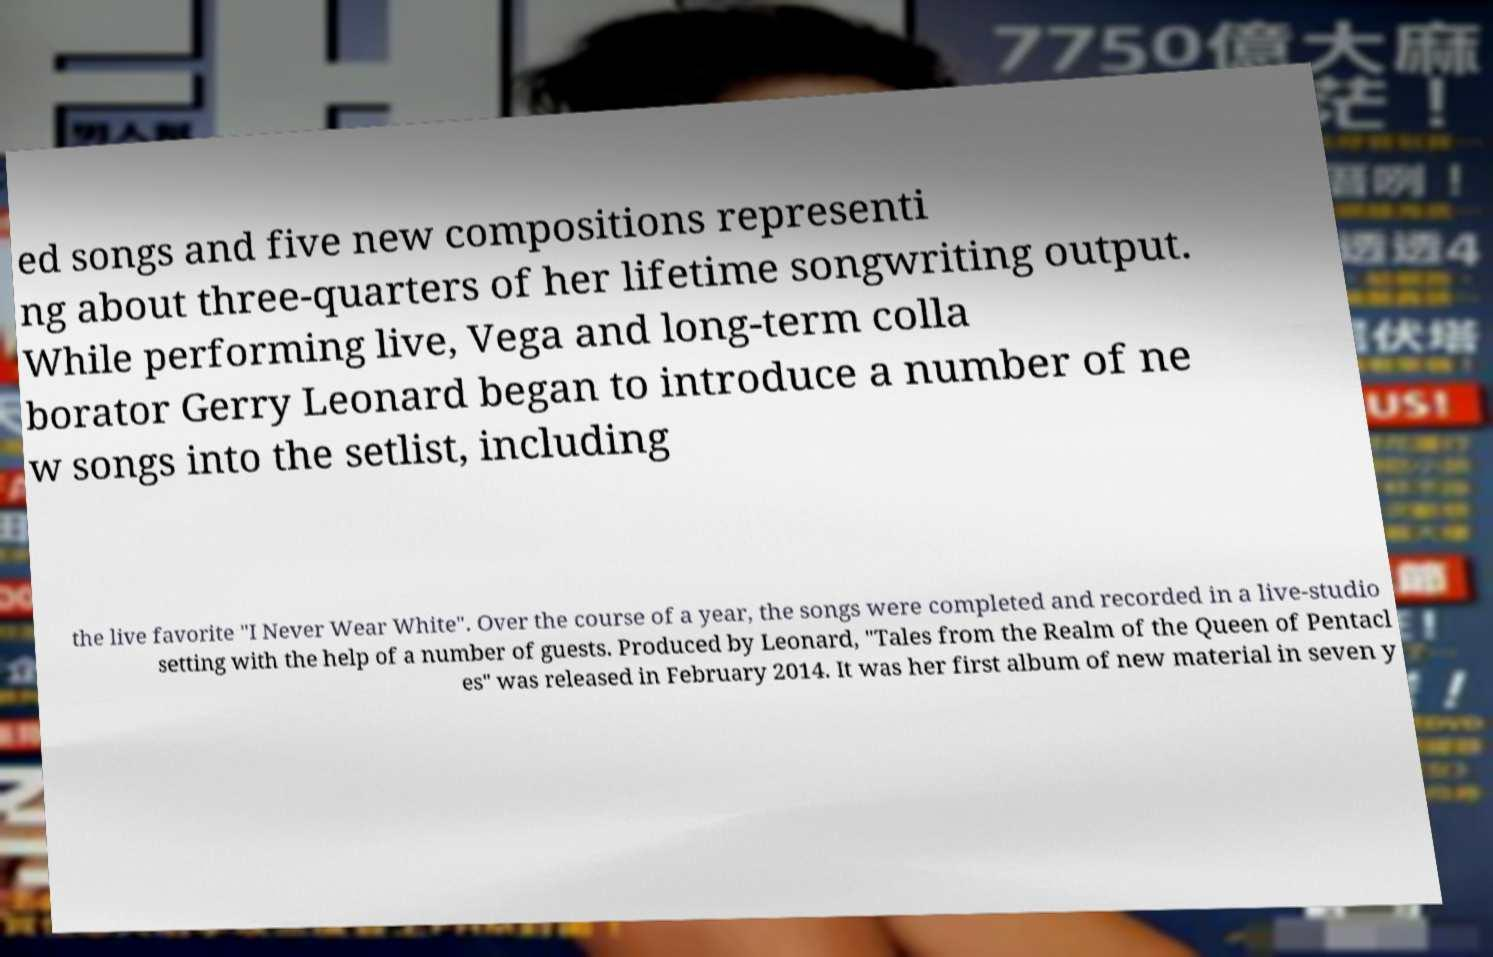What messages or text are displayed in this image? I need them in a readable, typed format. ed songs and five new compositions representi ng about three-quarters of her lifetime songwriting output. While performing live, Vega and long-term colla borator Gerry Leonard began to introduce a number of ne w songs into the setlist, including the live favorite "I Never Wear White". Over the course of a year, the songs were completed and recorded in a live-studio setting with the help of a number of guests. Produced by Leonard, "Tales from the Realm of the Queen of Pentacl es" was released in February 2014. It was her first album of new material in seven y 